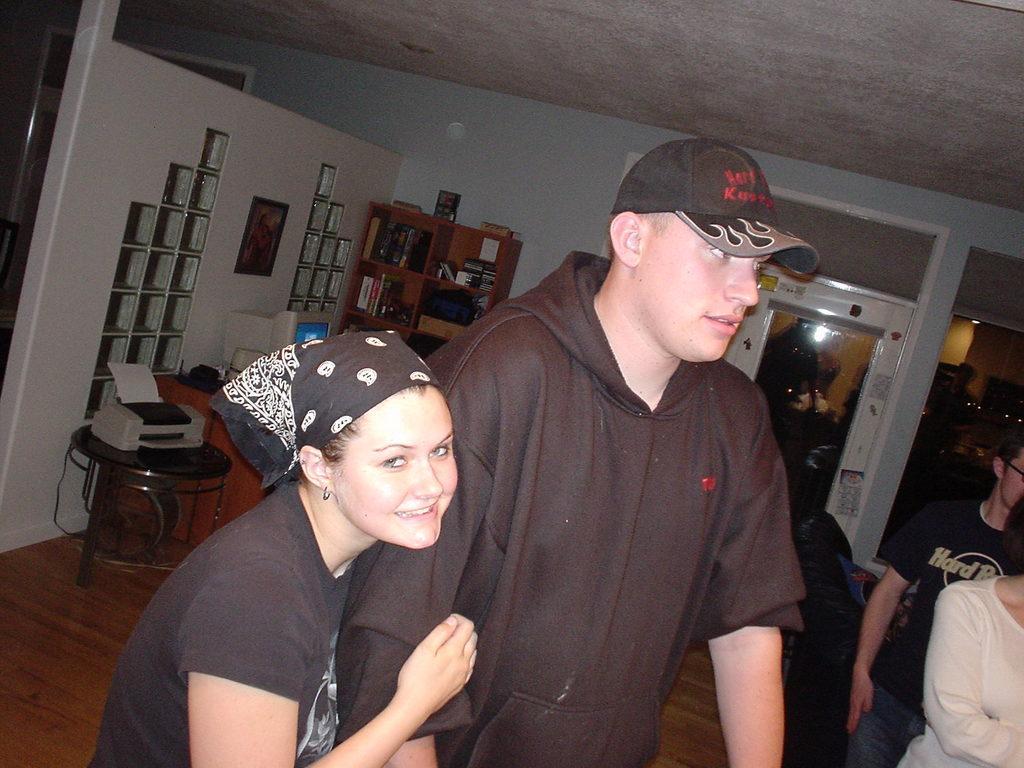Could you give a brief overview of what you see in this image? In the picture I can see a woman wearing black color T-shirt and scarf on her head is smiling and holding a man who is wearing black color sweater and cap. In the background, I can see a few more people standing on the wooden floor. Here on the left side of the image I can see a printer placed on the table, I can see a computer and few more objects are also placed on the table, I can see the photo frame on the wall, I can see some objects are placed in the wooden cupboard and in the background, I can see the door. 